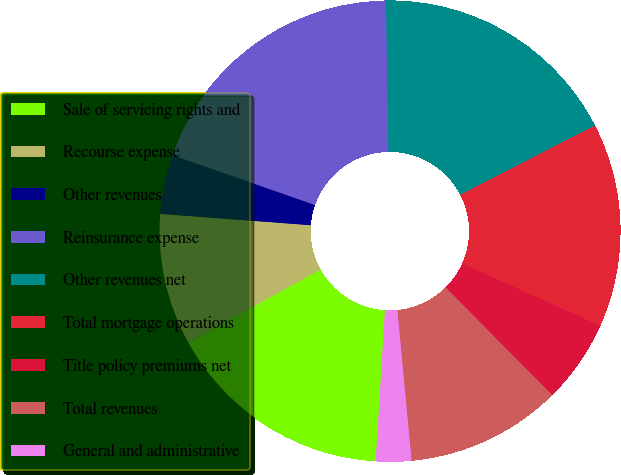Convert chart to OTSL. <chart><loc_0><loc_0><loc_500><loc_500><pie_chart><fcel>Sale of servicing rights and<fcel>Recourse expense<fcel>Other revenues<fcel>Reinsurance expense<fcel>Other revenues net<fcel>Total mortgage operations<fcel>Title policy premiums net<fcel>Total revenues<fcel>General and administrative<nl><fcel>15.99%<fcel>9.23%<fcel>4.16%<fcel>19.38%<fcel>17.69%<fcel>14.3%<fcel>5.85%<fcel>10.92%<fcel>2.47%<nl></chart> 